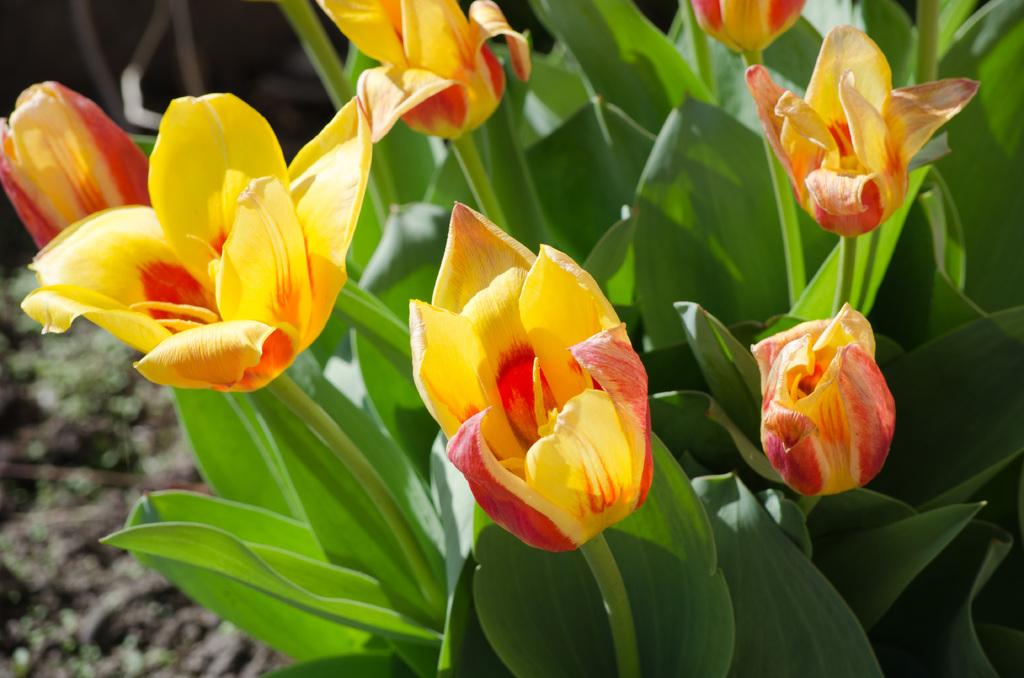What type of plants are visible in the image? There are plants with flowers in the image. What can be seen in the background of the image? The background of the image includes the ground. How would you describe the background's appearance? The background appears blurry. What time of day is it in the image, and how is the tray used in this scene? There is no mention of a tray in the image, and the time of day cannot be determined from the provided facts. 